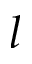<formula> <loc_0><loc_0><loc_500><loc_500>l</formula> 